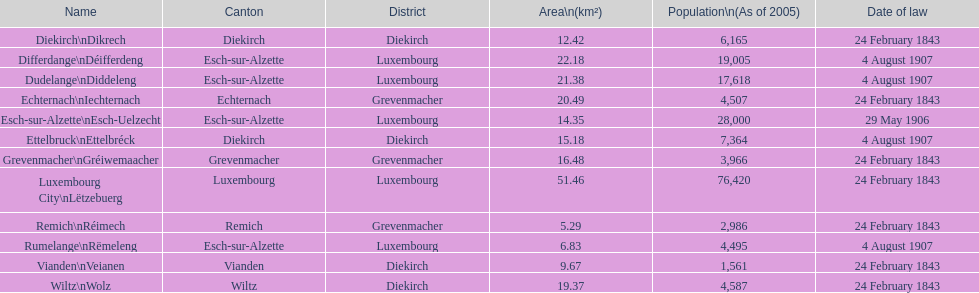How many urban areas in luxembourg had a legislation date of february 24, 1843? 7. Would you be able to parse every entry in this table? {'header': ['Name', 'Canton', 'District', 'Area\\n(km²)', 'Population\\n(As of 2005)', 'Date of law'], 'rows': [['Diekirch\\nDikrech', 'Diekirch', 'Diekirch', '12.42', '6,165', '24 February 1843'], ['Differdange\\nDéifferdeng', 'Esch-sur-Alzette', 'Luxembourg', '22.18', '19,005', '4 August 1907'], ['Dudelange\\nDiddeleng', 'Esch-sur-Alzette', 'Luxembourg', '21.38', '17,618', '4 August 1907'], ['Echternach\\nIechternach', 'Echternach', 'Grevenmacher', '20.49', '4,507', '24 February 1843'], ['Esch-sur-Alzette\\nEsch-Uelzecht', 'Esch-sur-Alzette', 'Luxembourg', '14.35', '28,000', '29 May 1906'], ['Ettelbruck\\nEttelbréck', 'Diekirch', 'Diekirch', '15.18', '7,364', '4 August 1907'], ['Grevenmacher\\nGréiwemaacher', 'Grevenmacher', 'Grevenmacher', '16.48', '3,966', '24 February 1843'], ['Luxembourg City\\nLëtzebuerg', 'Luxembourg', 'Luxembourg', '51.46', '76,420', '24 February 1843'], ['Remich\\nRéimech', 'Remich', 'Grevenmacher', '5.29', '2,986', '24 February 1843'], ['Rumelange\\nRëmeleng', 'Esch-sur-Alzette', 'Luxembourg', '6.83', '4,495', '4 August 1907'], ['Vianden\\nVeianen', 'Vianden', 'Diekirch', '9.67', '1,561', '24 February 1843'], ['Wiltz\\nWolz', 'Wiltz', 'Diekirch', '19.37', '4,587', '24 February 1843']]} 